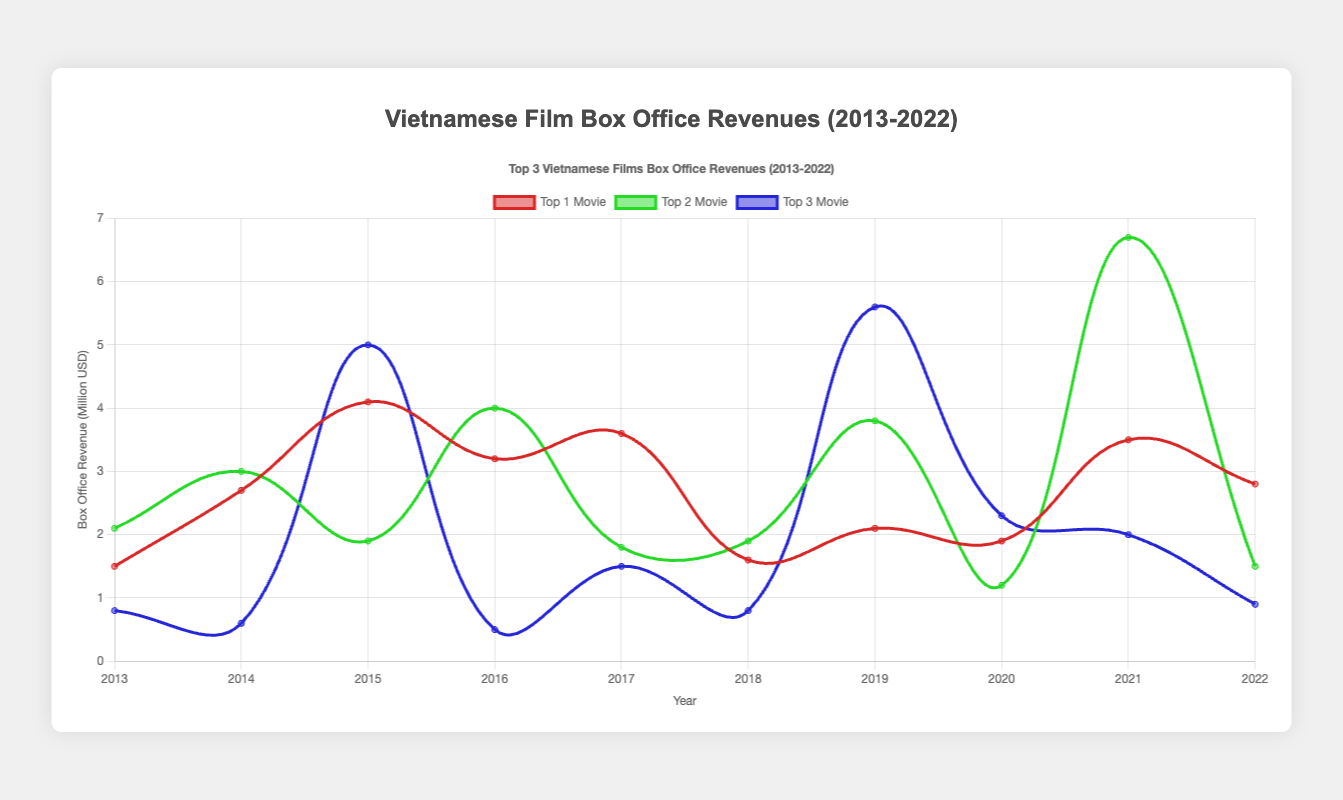Which year had the highest box office revenue for the top 1 movie? To find the answer, look at the dataset for the "Top 1 Movie" line and identify the highest value. This value appears to be 6.7 (million USD) in 2021 for "Bo Gia."
Answer: 2021 Between 2020 and 2021, which year had a greater box office revenue for the top 2 movie? Compare the revenue of the top 2 movies for both years: 4.0 (million USD) in 2021 ("Camellia Sisters") and 1.2 (million USD) in 2020 ("Love Again"). 2021 has higher revenue.
Answer: 2021 What is the sum of the top 3 movie revenues in 2018? Add the revenues of the top 3 movies in 2018: 1.6 (million USD) for "The Tailor," 1.9 (million USD) for "Gái Già Lắm Chiêu 2," and 0.8 (million USD) for "Song Lang." Sum = 1.6 + 1.9 + 0.8 = 4.3 (million USD).
Answer: 4.3 Which movie had the highest box office revenue in 2015? Compare the revenues of the movies in 2015: "I Am Your Grandmother" at 4.1 (million USD), "Fury" at 1.9 (million USD), and "Sweet 20" at 5.0 (million USD). "Sweet 20" has the highest revenue.
Answer: Sweet 20 How did the total revenue of the top 1 movie in 2013 compare to 2016? Compare the revenues of the top 1 movie: "Thien Menh Anh Hung" in 2013 with 2.1 (million USD) and "Tấm Cám: The Untold Story" in 2016 with 4.0 (million USD). 2016's revenue is greater.
Answer: 2016 What is the average revenue of the top 3 movies in 2020? Calculate the average revenue by adding the revenues: 1.9 (million USD) for "Blood Moon Party," 1.2 (million USD) for "Love Again," and 2.3 (million USD) for "Dreamy Eyes," and then dividing by 3. Sum = 1.9 + 1.2 + 2.3 = 5.4 (million USD), average = 5.4 / 3 = 1.8 (million USD).
Answer: 1.8 Did any year have all three movies making over 2 million USD each at the box office? Check each year's data to see if all three movies exceed 2 million USD. Only 2021 meets this criterion: "Dad, I’m Sorry" (3.5 million USD), "Bo Gia" (6.7 million USD), and "Camellia Sisters" (2.0 million USD).
Answer: 2021 Which movie category (top 1, top 2, or top 3) shows the least variance in revenue over the years? Calculate the variance in revenues for each movie category (Top 1, Top 2, Top 3) and compare. The top 3 movie line has the least visible changes, suggesting the least variance.
Answer: Top 3 